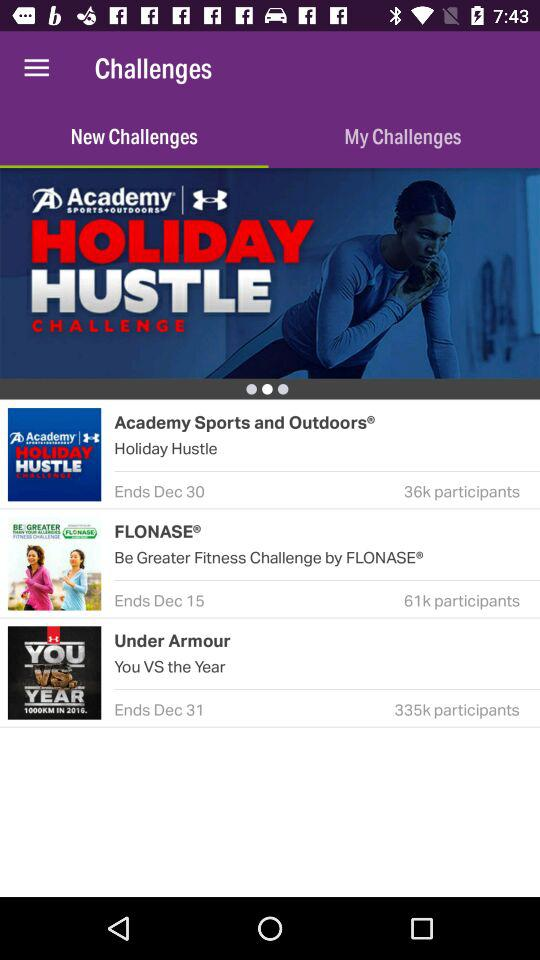What is the end date of "Under Armour"? The end date is December 31. 